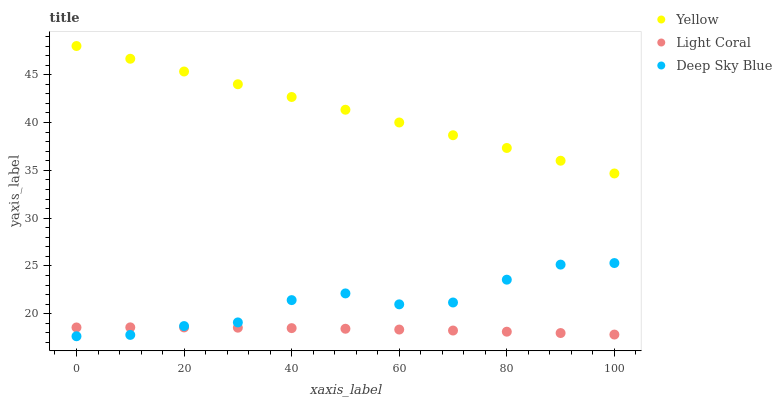Does Light Coral have the minimum area under the curve?
Answer yes or no. Yes. Does Yellow have the maximum area under the curve?
Answer yes or no. Yes. Does Deep Sky Blue have the minimum area under the curve?
Answer yes or no. No. Does Deep Sky Blue have the maximum area under the curve?
Answer yes or no. No. Is Yellow the smoothest?
Answer yes or no. Yes. Is Deep Sky Blue the roughest?
Answer yes or no. Yes. Is Deep Sky Blue the smoothest?
Answer yes or no. No. Is Yellow the roughest?
Answer yes or no. No. Does Deep Sky Blue have the lowest value?
Answer yes or no. Yes. Does Yellow have the lowest value?
Answer yes or no. No. Does Yellow have the highest value?
Answer yes or no. Yes. Does Deep Sky Blue have the highest value?
Answer yes or no. No. Is Light Coral less than Yellow?
Answer yes or no. Yes. Is Yellow greater than Deep Sky Blue?
Answer yes or no. Yes. Does Light Coral intersect Deep Sky Blue?
Answer yes or no. Yes. Is Light Coral less than Deep Sky Blue?
Answer yes or no. No. Is Light Coral greater than Deep Sky Blue?
Answer yes or no. No. Does Light Coral intersect Yellow?
Answer yes or no. No. 